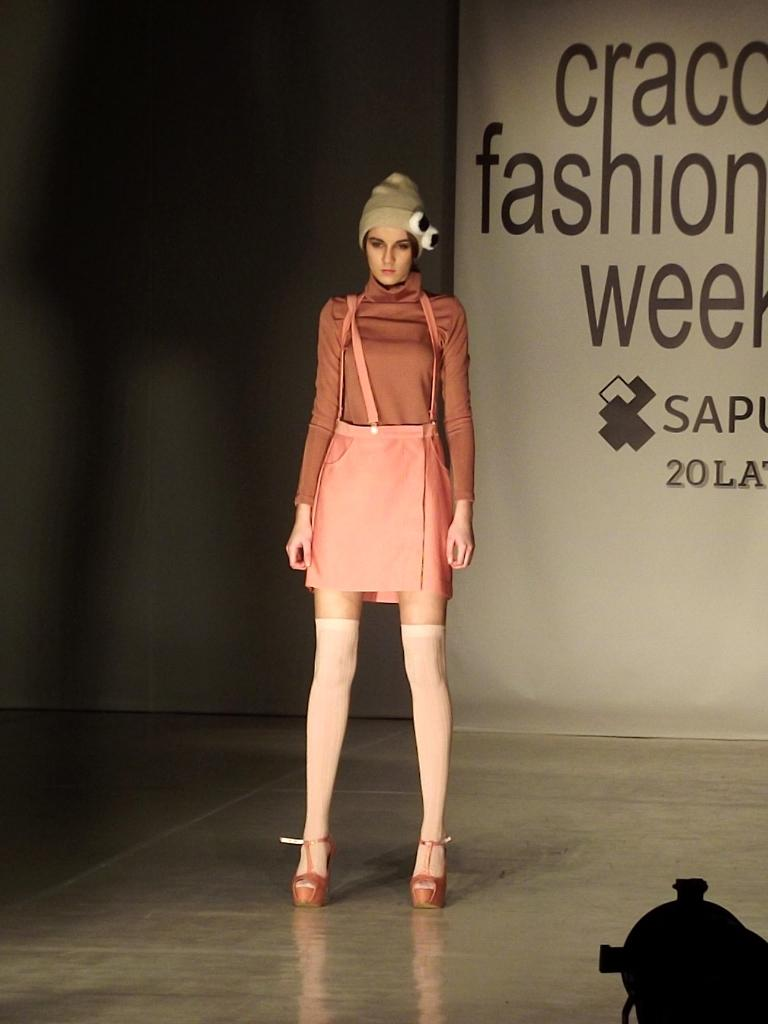Who is the main subject in the image? There is a woman standing in the center of the image. What is the woman's position in relation to the ground? The woman is standing on the floor. What can be seen in the bottom right corner of the image? There is an object in the bottom right corner of the image. What is written or displayed on the banner in the background? There is visible on a banner in the background of the image? What type of shoe is the woman wearing in the image? There is no shoe visible in the image; the woman is standing on the floor without any footwear. 